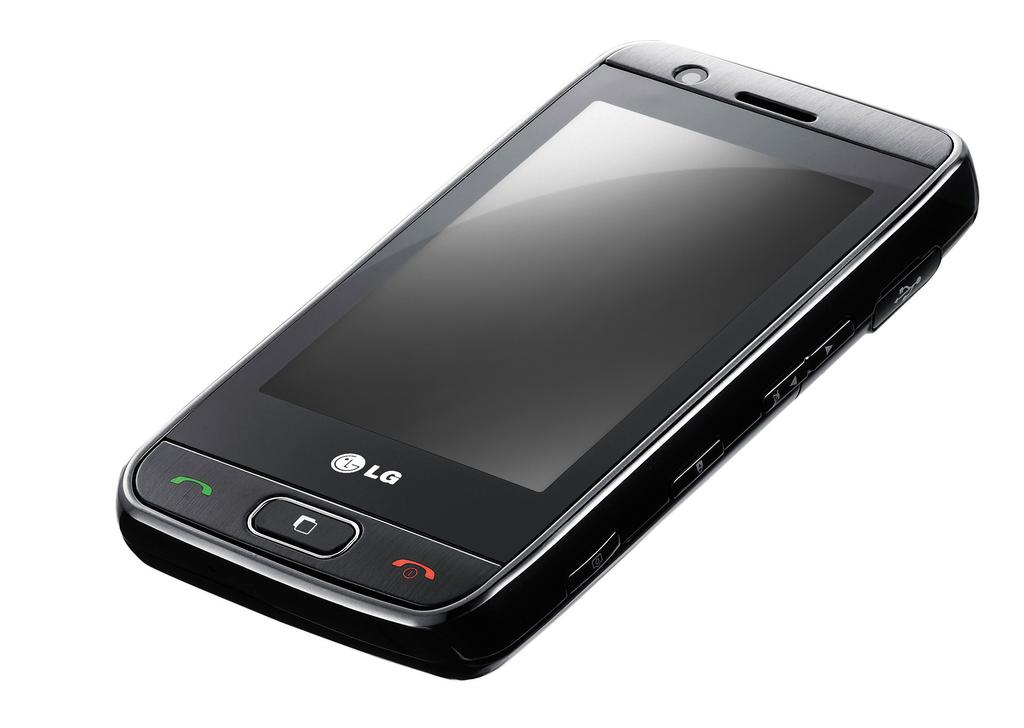<image>
Provide a brief description of the given image. Black LG cellphone with a green and red button near the button. 